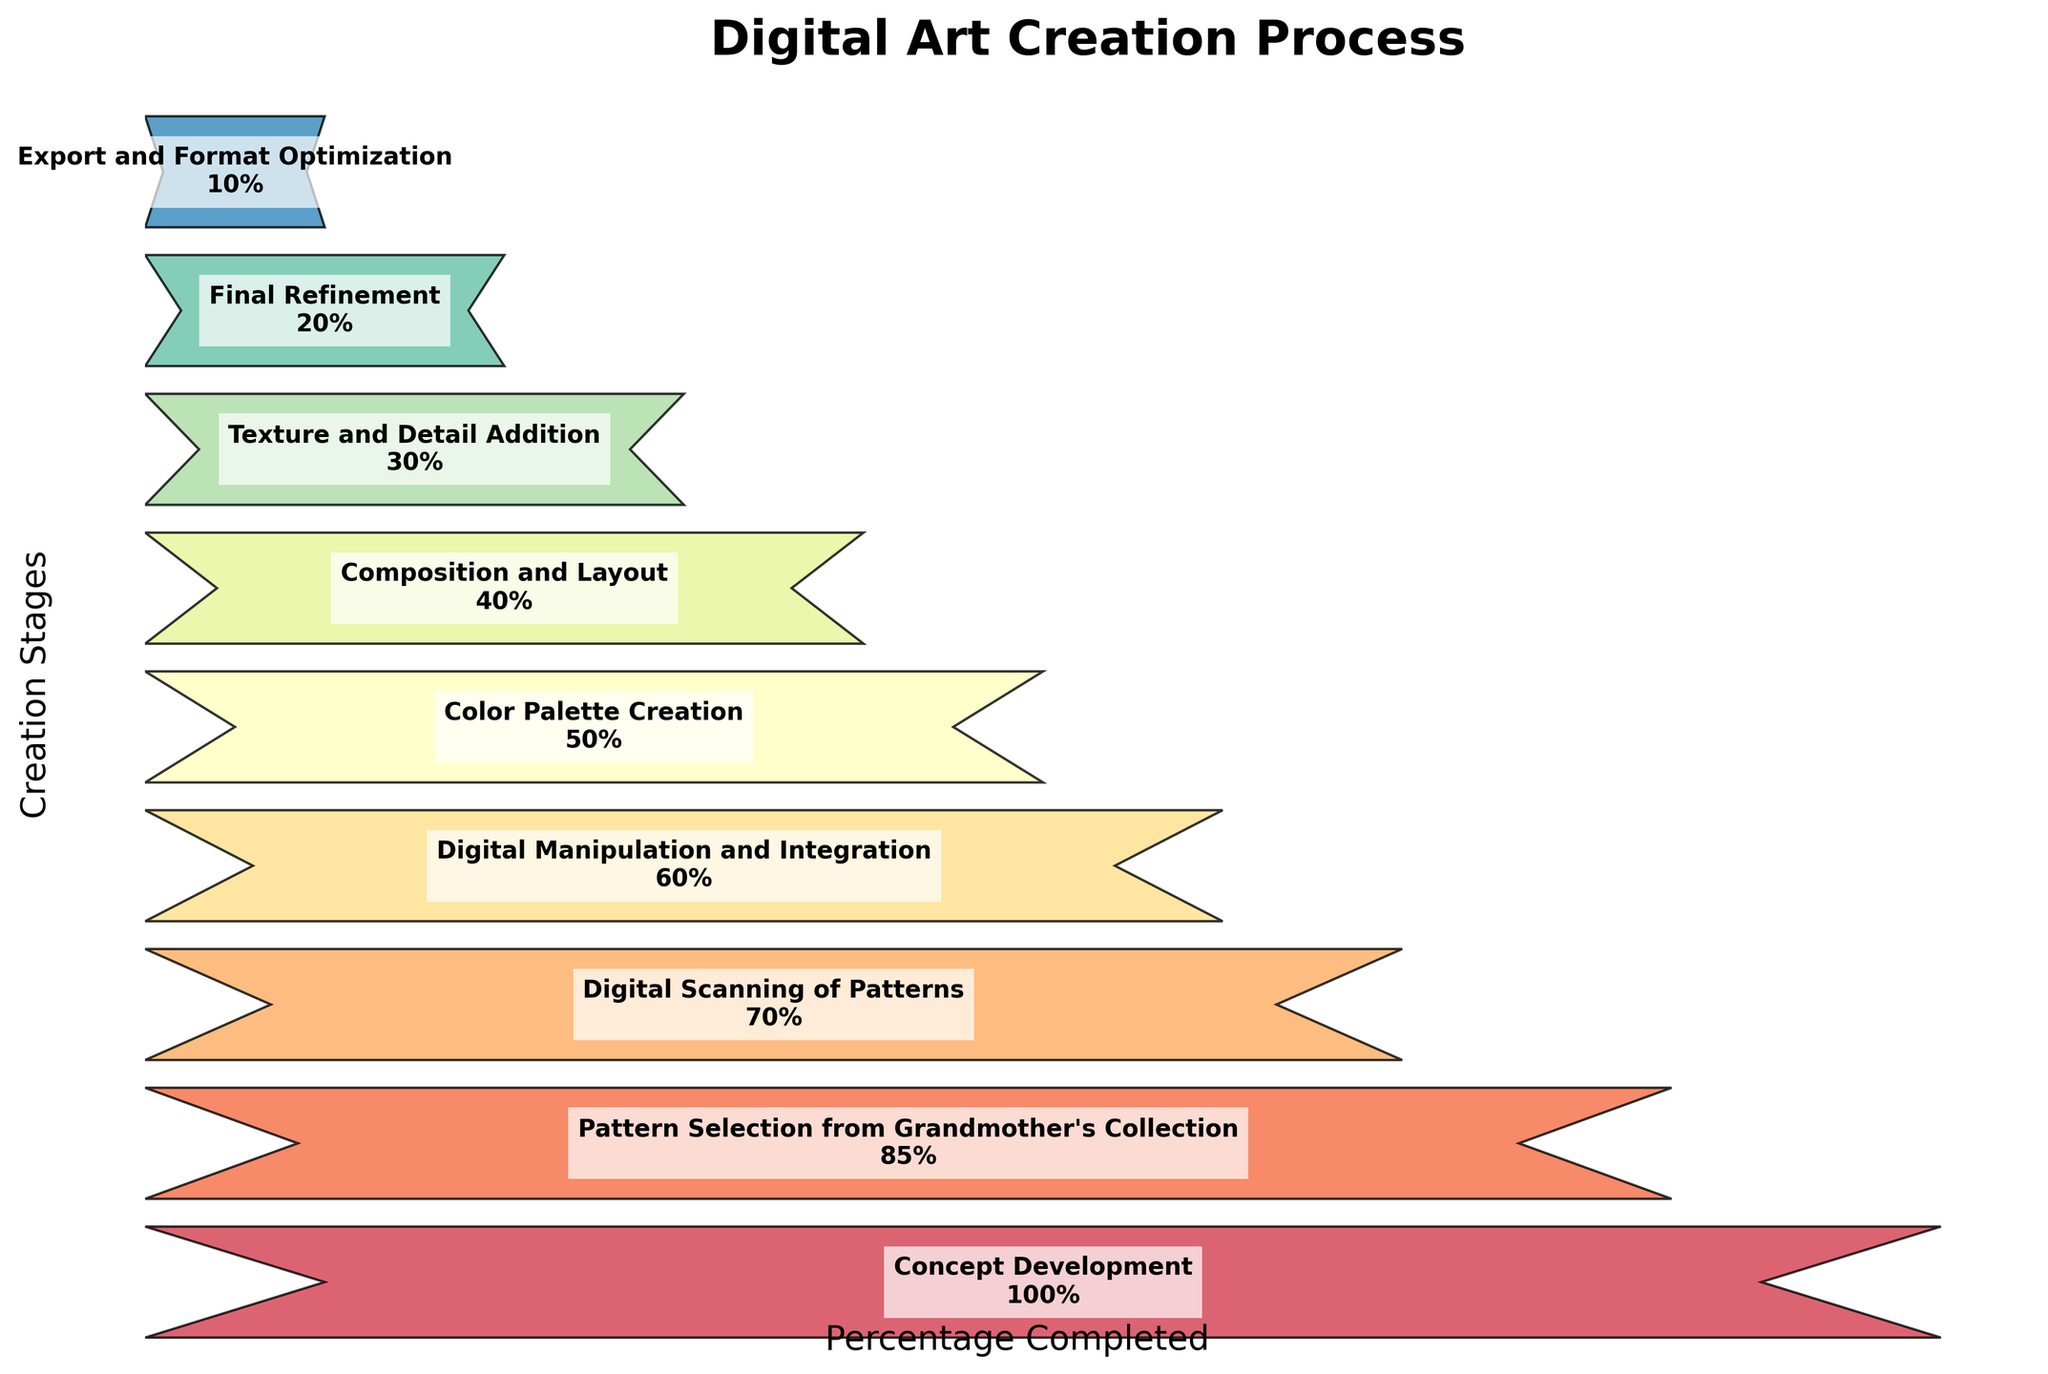What is the title of the Funnel Chart? The title of the plot is typically displayed at the top of the figure. It summarizes the content of the chart. The title is "Digital Art Creation Process."
Answer: Digital Art Creation Process How many stages are there in the digital art creation process according to the Funnel Chart? By counting the number of distinct stages in the plot, we can determine the total number of stages. There are 9 stages listed.
Answer: 9 What is the percentage completed for the pattern selection stage? The percentage for each stage is listed next to the stage name on the chart. For "Pattern Selection from Grandmother's Collection," it shows 85%.
Answer: 85% Which stage shows the biggest drop in percentage compared to the previous stage? To find the biggest drop, compare the difference in percentages between subsequent stages. The difference between "Digital Scanning of Patterns" (70%) and "Pattern Selection from Grandmother's Collection" (85%) is the largest at 15%.
Answer: Digital Scanning of Patterns What is the percentage reduction from concept development to final refinement? The percentage at the "Concept Development" stage is 100%, and at "Final Refinement" stage it is 20%. The reduction is 100% - 20%, so 80%.
Answer: 80% How much percentage remains after the color palette creation stage? The percentage at "Color Palette Creation" is 50%. The subsequent stage, "Composition and Layout," shows 40%, so 40% remains.
Answer: 40% Compare the percentages between digital manipulation and texture/detail addition stages. Which is greater? The "Digital Manipulation and Integration" stage is at 60% and "Texture and Detail Addition" is at 30%. Therefore, 60% is greater than 30%.
Answer: Digital Manipulation and Integration Estimate the average percentage of the stages after digital scanning including it. Calculate the average percentage from "Digital Scanning of Patterns" (70%) to "Export and Format Optimization" (10%). Add the percentages: 70 + 60 + 50 + 40 + 30 + 20 + 10 = 280. There are 7 stages, so 280/7 = 40%.
Answer: 40% What is the difference in percentage between "Composition and Layout" and "Final Refinement"? The percentage at "Composition and Layout" is 40%, and "Final Refinement" is 20%. The difference is 40% - 20% = 20%.
Answer: 20% According to the funnel chart, which stage immediately follows pattern selection? By reading the stages in order from top to bottom, "Digital Scanning of Patterns" follows "Pattern Selection from Grandmother's Collection."
Answer: Digital Scanning of Patterns 